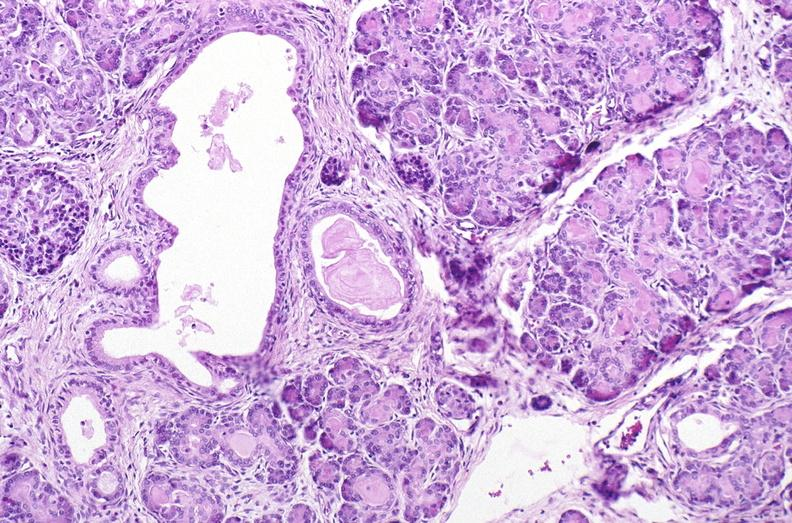where is this?
Answer the question using a single word or phrase. Pancreas 